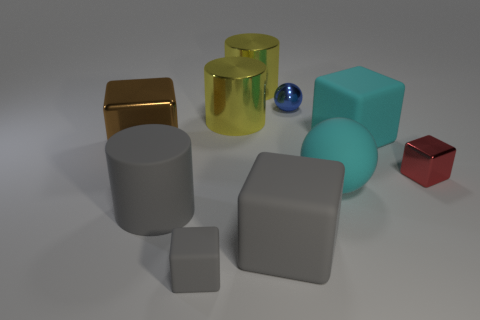Subtract all cyan blocks. How many blocks are left? 4 Subtract all small metallic cubes. How many cubes are left? 4 Subtract all cyan blocks. Subtract all yellow spheres. How many blocks are left? 4 Subtract all cylinders. How many objects are left? 7 Subtract all matte objects. Subtract all yellow rubber balls. How many objects are left? 5 Add 4 cyan matte objects. How many cyan matte objects are left? 6 Add 10 small red rubber things. How many small red rubber things exist? 10 Subtract 1 blue balls. How many objects are left? 9 